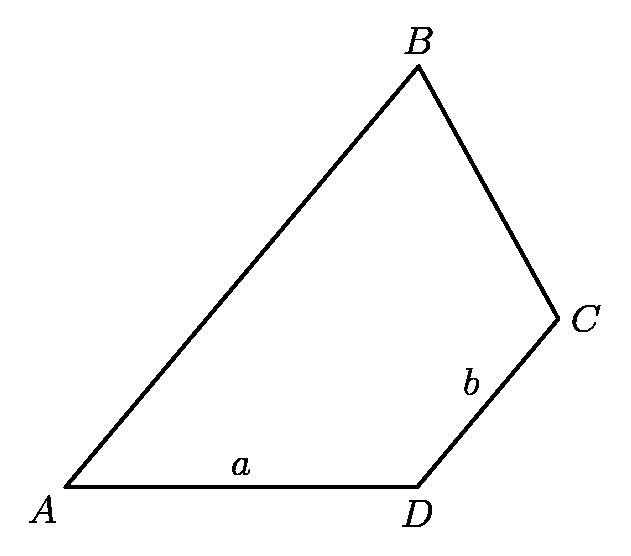In the accompanying figure, segments $AB$ and $CD$ are parallel, the measure of angle $D$ is twice the measure of angle $B$, and the measures of segments $AB$ and $CD$ are $a$ and $b$ respectively.
Then the measure of $AB$ is equal to Choices: ['$\\frac{1}{2}a+2b$', '$\\frac{3}{2}b+\\frac{3}{4}a$', '$2a-b$', '$4b-\\frac{1}{2}a$', '$a+b$'] To determine the actual measure of $AB$ from the choices provided, we need more information about the relationship between $a$ and $b$ and the specific measures or proportionality of angles in the diagram. Without such additional data, especially regarding the angles and lengths proportion, it's challenging to definitively choose among the given options. It's essential to have further context or geometric properties defined to solve this question accurately. Assuming an understanding of basic geometric relationships and without specific numeric measures, the possible choice could be analyzed through algebraic relationships or geometric postulates. 